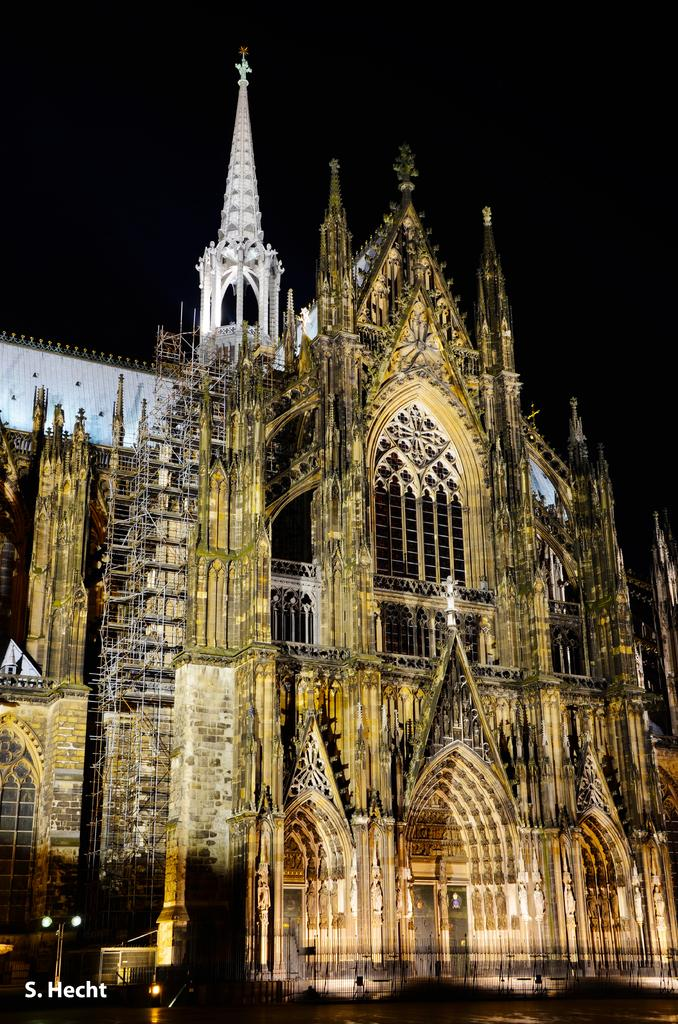What is the main subject in the center of the image? There is a church in the center of the image. What else can be seen in the image besides the church? There are lights visible in the image. What is visible at the top of the image? The sky is visible at the top of the image. How many girls are playing volleyball in the image? There are no girls or volleyball present in the image. What type of stick is being used by the person in the image? There is no person or stick present in the image. 